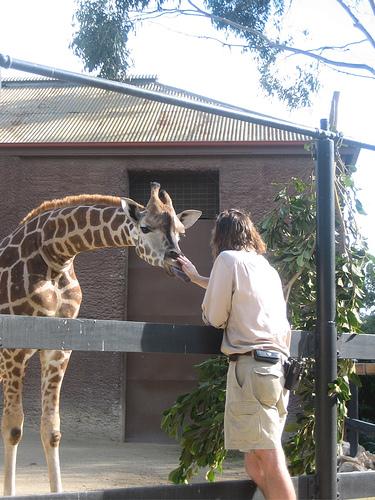Is the animal contained?
Write a very short answer. Yes. What does this animal eat?
Answer briefly. Leaves. Does the person work at the zoo?
Answer briefly. Yes. 